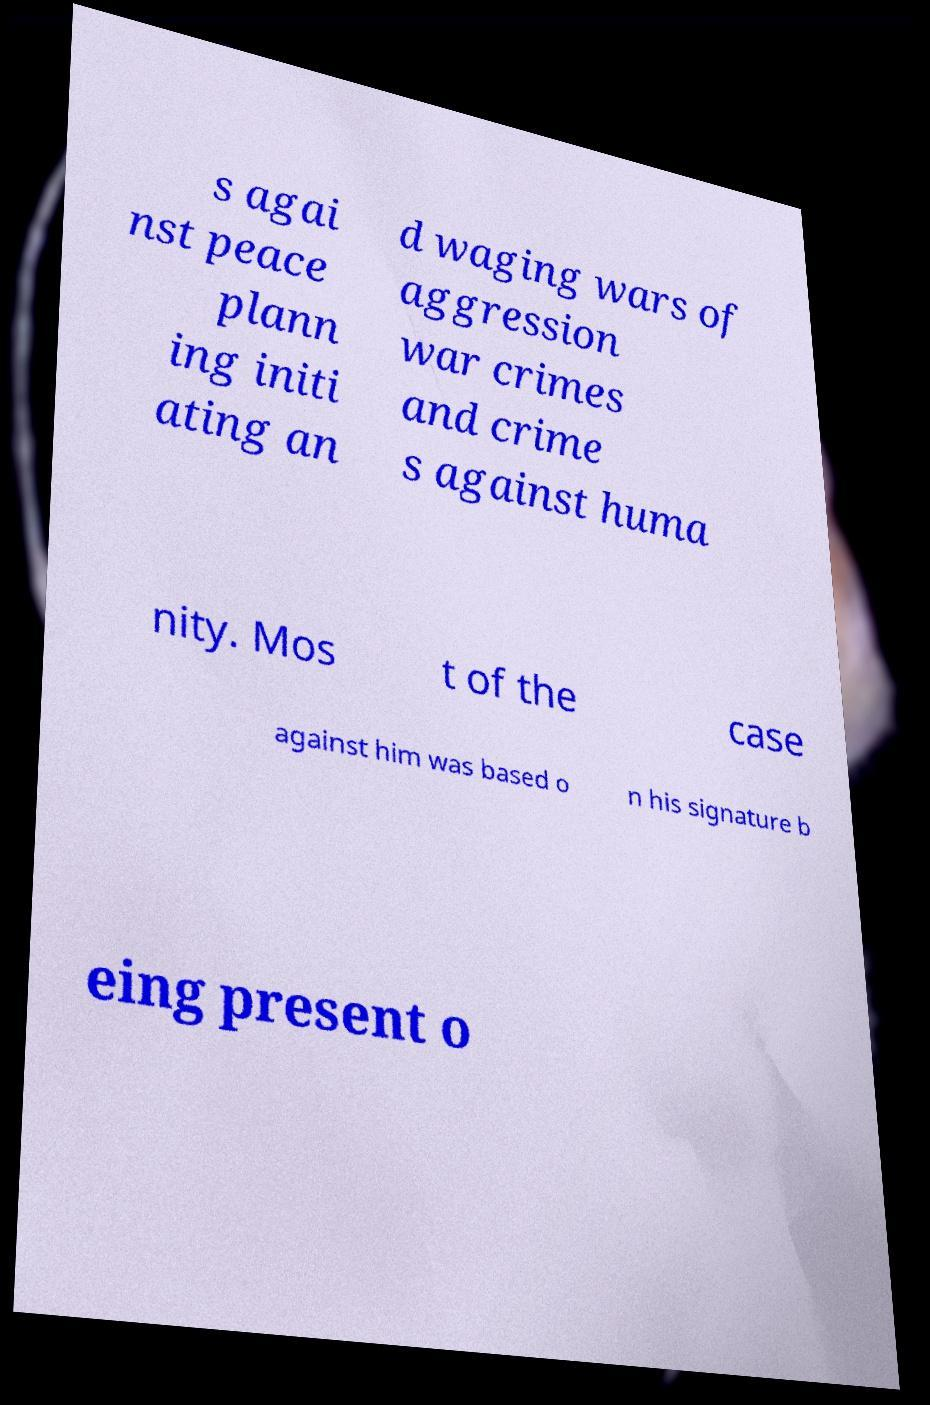Could you extract and type out the text from this image? s agai nst peace plann ing initi ating an d waging wars of aggression war crimes and crime s against huma nity. Mos t of the case against him was based o n his signature b eing present o 